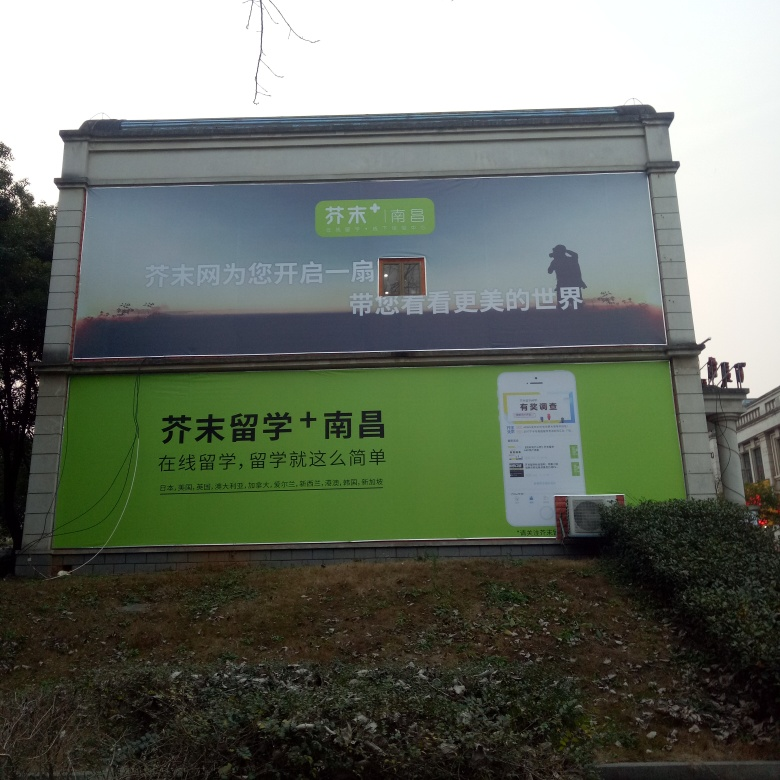Why is the image clarity of this photo considered relatively high? The image clarity of this photo can be considered relatively high because the text on the billboard is legible and the details such as the phone screen graphic and environmental elements are distinguishable. This maintains a good balance of sharpness and detail across various components of the image. 